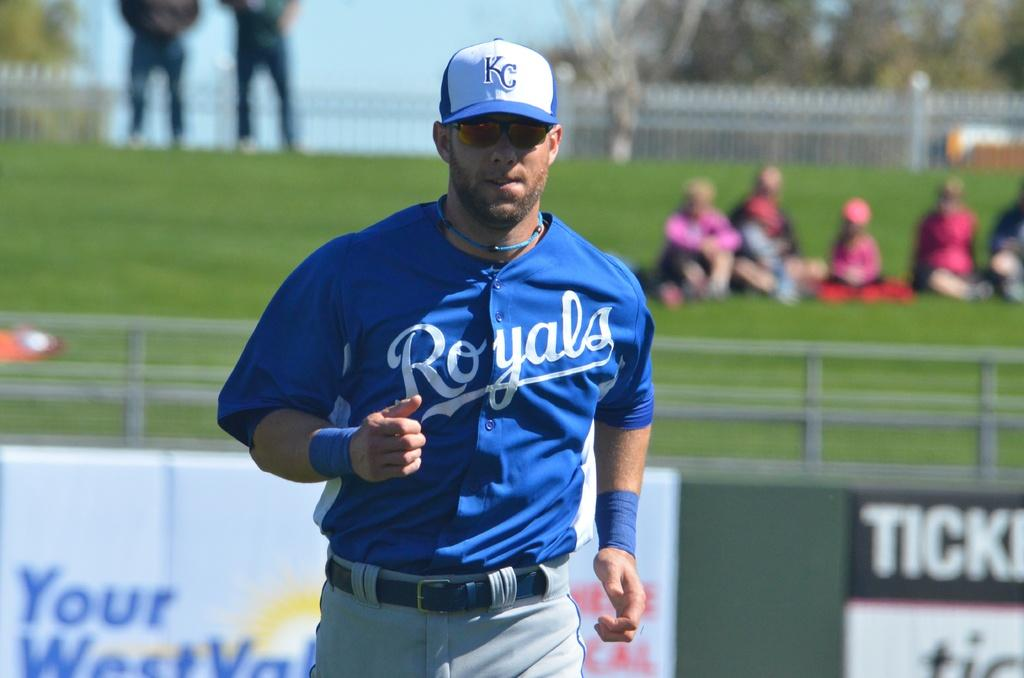<image>
Render a clear and concise summary of the photo. Man wearing a blue Royals jersey running on base. 